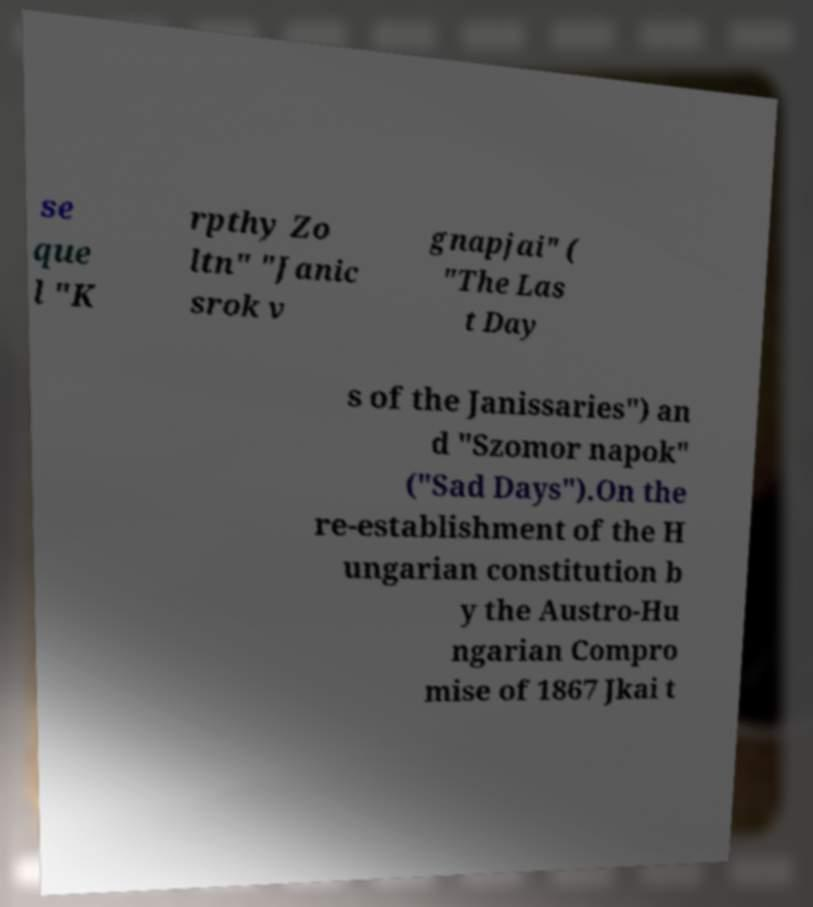I need the written content from this picture converted into text. Can you do that? se que l "K rpthy Zo ltn" "Janic srok v gnapjai" ( "The Las t Day s of the Janissaries") an d "Szomor napok" ("Sad Days").On the re-establishment of the H ungarian constitution b y the Austro-Hu ngarian Compro mise of 1867 Jkai t 